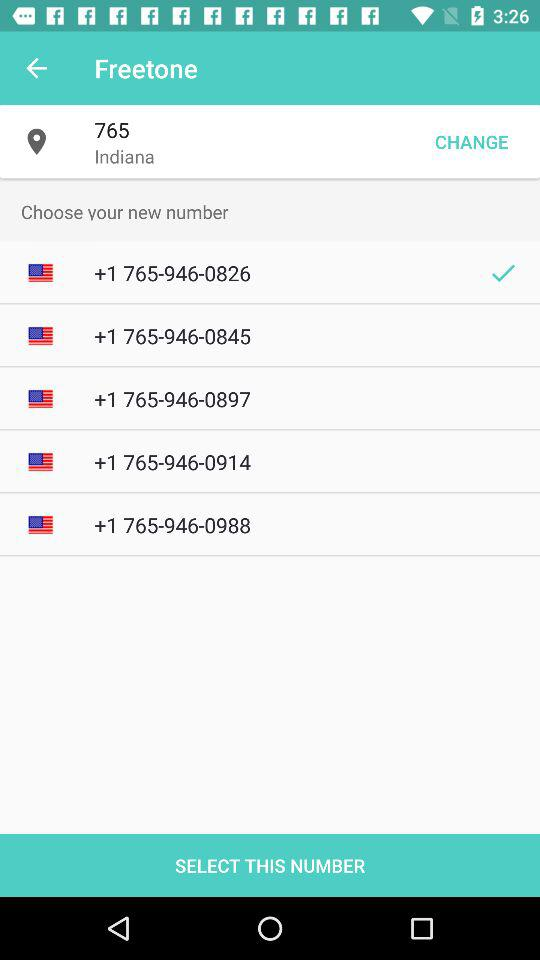What is the current location? The current location is Indiana. 